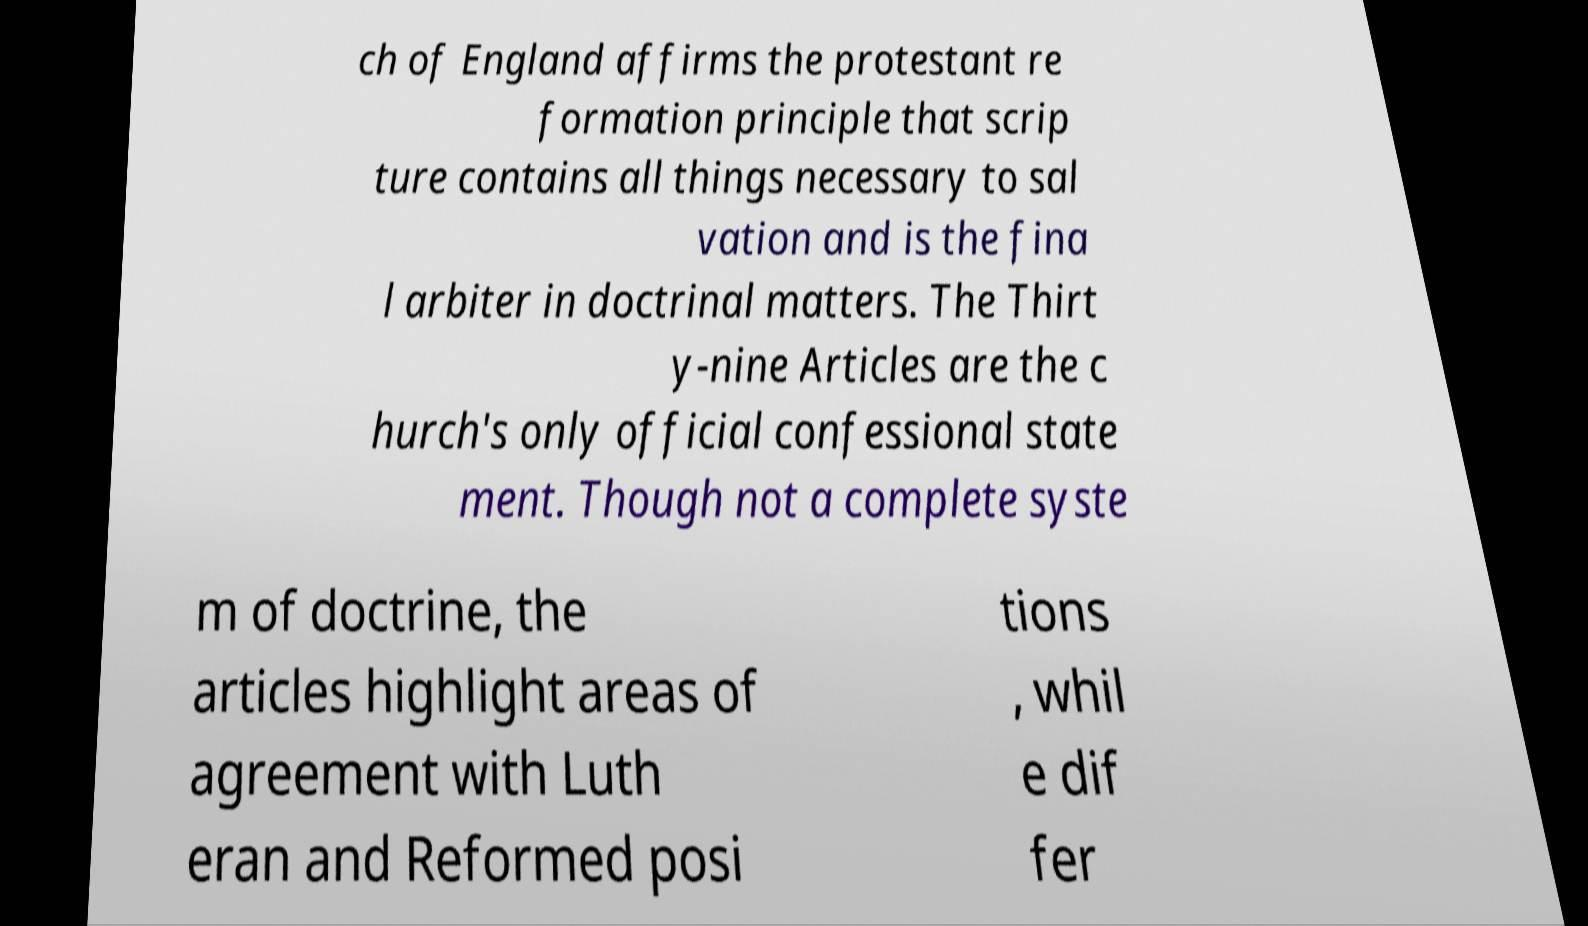I need the written content from this picture converted into text. Can you do that? ch of England affirms the protestant re formation principle that scrip ture contains all things necessary to sal vation and is the fina l arbiter in doctrinal matters. The Thirt y-nine Articles are the c hurch's only official confessional state ment. Though not a complete syste m of doctrine, the articles highlight areas of agreement with Luth eran and Reformed posi tions , whil e dif fer 